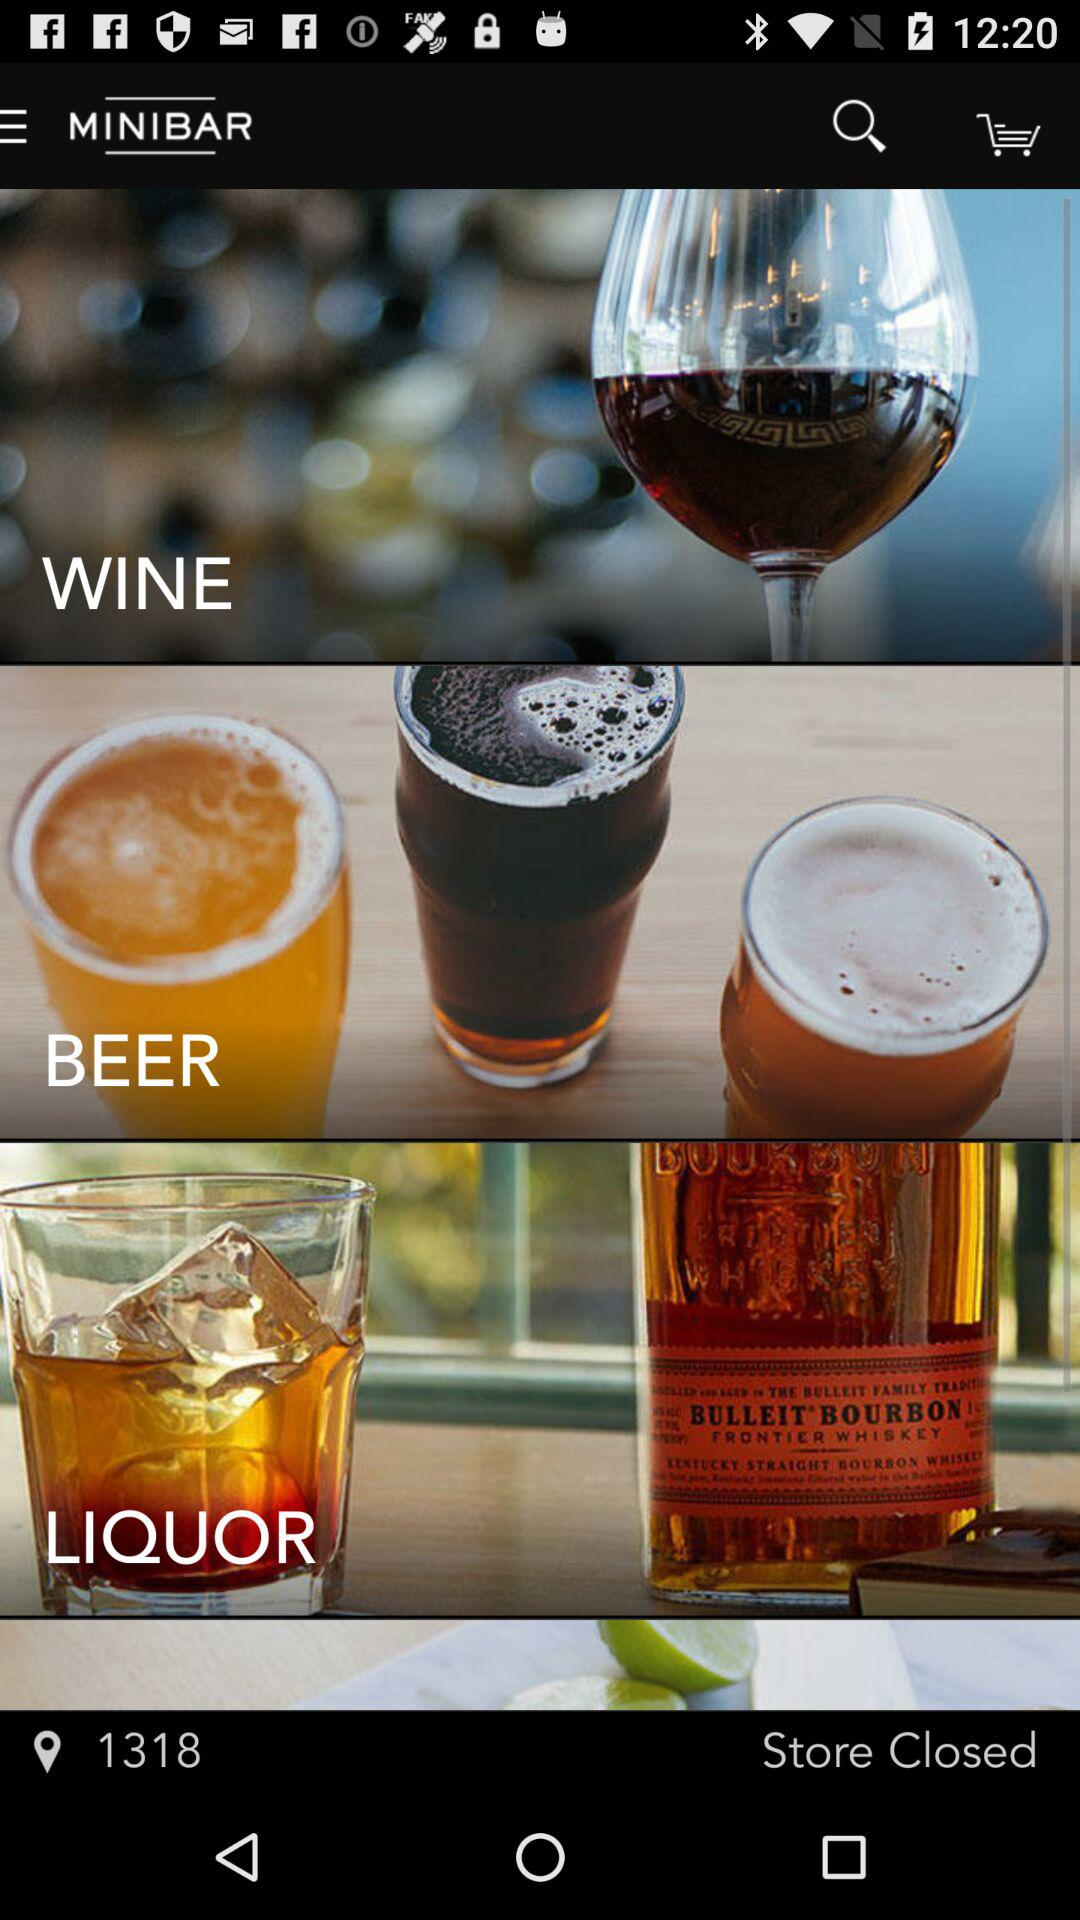What is the location number? The location number is 1318. 